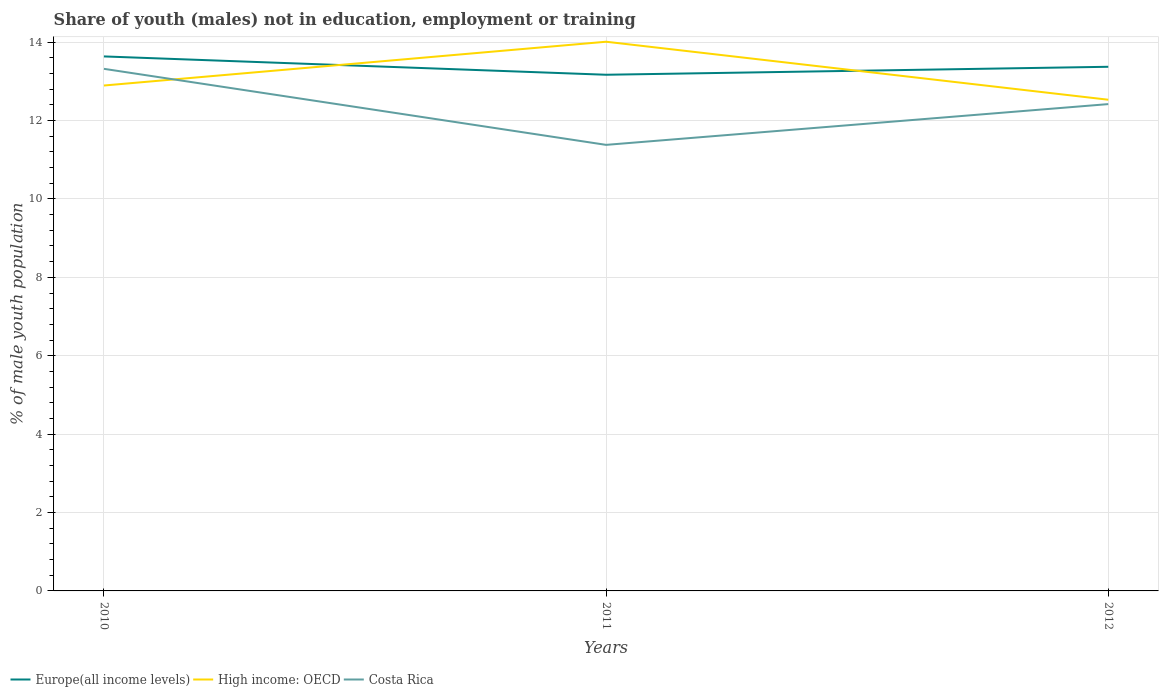How many different coloured lines are there?
Make the answer very short. 3. Does the line corresponding to High income: OECD intersect with the line corresponding to Europe(all income levels)?
Provide a succinct answer. Yes. Across all years, what is the maximum percentage of unemployed males population in in Costa Rica?
Your response must be concise. 11.38. In which year was the percentage of unemployed males population in in Costa Rica maximum?
Offer a very short reply. 2011. What is the total percentage of unemployed males population in in High income: OECD in the graph?
Your answer should be compact. 0.36. What is the difference between the highest and the second highest percentage of unemployed males population in in Europe(all income levels)?
Keep it short and to the point. 0.47. What is the difference between the highest and the lowest percentage of unemployed males population in in High income: OECD?
Provide a succinct answer. 1. How many years are there in the graph?
Your answer should be very brief. 3. Does the graph contain grids?
Your response must be concise. Yes. Where does the legend appear in the graph?
Provide a succinct answer. Bottom left. How many legend labels are there?
Offer a terse response. 3. What is the title of the graph?
Provide a succinct answer. Share of youth (males) not in education, employment or training. Does "Sweden" appear as one of the legend labels in the graph?
Keep it short and to the point. No. What is the label or title of the Y-axis?
Keep it short and to the point. % of male youth population. What is the % of male youth population of Europe(all income levels) in 2010?
Your answer should be very brief. 13.64. What is the % of male youth population in High income: OECD in 2010?
Offer a very short reply. 12.89. What is the % of male youth population in Costa Rica in 2010?
Provide a short and direct response. 13.32. What is the % of male youth population of Europe(all income levels) in 2011?
Offer a very short reply. 13.17. What is the % of male youth population of High income: OECD in 2011?
Your response must be concise. 14.01. What is the % of male youth population of Costa Rica in 2011?
Offer a very short reply. 11.38. What is the % of male youth population of Europe(all income levels) in 2012?
Provide a short and direct response. 13.37. What is the % of male youth population in High income: OECD in 2012?
Your response must be concise. 12.53. What is the % of male youth population in Costa Rica in 2012?
Make the answer very short. 12.42. Across all years, what is the maximum % of male youth population in Europe(all income levels)?
Ensure brevity in your answer.  13.64. Across all years, what is the maximum % of male youth population of High income: OECD?
Offer a very short reply. 14.01. Across all years, what is the maximum % of male youth population in Costa Rica?
Offer a terse response. 13.32. Across all years, what is the minimum % of male youth population of Europe(all income levels)?
Keep it short and to the point. 13.17. Across all years, what is the minimum % of male youth population in High income: OECD?
Your answer should be compact. 12.53. Across all years, what is the minimum % of male youth population in Costa Rica?
Your answer should be compact. 11.38. What is the total % of male youth population in Europe(all income levels) in the graph?
Your response must be concise. 40.18. What is the total % of male youth population of High income: OECD in the graph?
Make the answer very short. 39.44. What is the total % of male youth population in Costa Rica in the graph?
Your response must be concise. 37.12. What is the difference between the % of male youth population of Europe(all income levels) in 2010 and that in 2011?
Ensure brevity in your answer.  0.47. What is the difference between the % of male youth population in High income: OECD in 2010 and that in 2011?
Your answer should be compact. -1.12. What is the difference between the % of male youth population in Costa Rica in 2010 and that in 2011?
Your response must be concise. 1.94. What is the difference between the % of male youth population of Europe(all income levels) in 2010 and that in 2012?
Offer a terse response. 0.26. What is the difference between the % of male youth population of High income: OECD in 2010 and that in 2012?
Your answer should be very brief. 0.36. What is the difference between the % of male youth population of Europe(all income levels) in 2011 and that in 2012?
Your answer should be very brief. -0.2. What is the difference between the % of male youth population of High income: OECD in 2011 and that in 2012?
Offer a very short reply. 1.48. What is the difference between the % of male youth population in Costa Rica in 2011 and that in 2012?
Keep it short and to the point. -1.04. What is the difference between the % of male youth population in Europe(all income levels) in 2010 and the % of male youth population in High income: OECD in 2011?
Make the answer very short. -0.37. What is the difference between the % of male youth population of Europe(all income levels) in 2010 and the % of male youth population of Costa Rica in 2011?
Provide a succinct answer. 2.26. What is the difference between the % of male youth population of High income: OECD in 2010 and the % of male youth population of Costa Rica in 2011?
Offer a terse response. 1.51. What is the difference between the % of male youth population in Europe(all income levels) in 2010 and the % of male youth population in High income: OECD in 2012?
Ensure brevity in your answer.  1.1. What is the difference between the % of male youth population of Europe(all income levels) in 2010 and the % of male youth population of Costa Rica in 2012?
Your answer should be compact. 1.22. What is the difference between the % of male youth population in High income: OECD in 2010 and the % of male youth population in Costa Rica in 2012?
Your answer should be very brief. 0.47. What is the difference between the % of male youth population in Europe(all income levels) in 2011 and the % of male youth population in High income: OECD in 2012?
Give a very brief answer. 0.64. What is the difference between the % of male youth population of Europe(all income levels) in 2011 and the % of male youth population of Costa Rica in 2012?
Your answer should be very brief. 0.75. What is the difference between the % of male youth population of High income: OECD in 2011 and the % of male youth population of Costa Rica in 2012?
Make the answer very short. 1.59. What is the average % of male youth population in Europe(all income levels) per year?
Your answer should be compact. 13.39. What is the average % of male youth population of High income: OECD per year?
Offer a very short reply. 13.15. What is the average % of male youth population of Costa Rica per year?
Your answer should be very brief. 12.37. In the year 2010, what is the difference between the % of male youth population of Europe(all income levels) and % of male youth population of High income: OECD?
Your answer should be very brief. 0.74. In the year 2010, what is the difference between the % of male youth population of Europe(all income levels) and % of male youth population of Costa Rica?
Your answer should be compact. 0.32. In the year 2010, what is the difference between the % of male youth population in High income: OECD and % of male youth population in Costa Rica?
Keep it short and to the point. -0.43. In the year 2011, what is the difference between the % of male youth population in Europe(all income levels) and % of male youth population in High income: OECD?
Keep it short and to the point. -0.84. In the year 2011, what is the difference between the % of male youth population in Europe(all income levels) and % of male youth population in Costa Rica?
Provide a short and direct response. 1.79. In the year 2011, what is the difference between the % of male youth population of High income: OECD and % of male youth population of Costa Rica?
Make the answer very short. 2.63. In the year 2012, what is the difference between the % of male youth population in Europe(all income levels) and % of male youth population in High income: OECD?
Provide a succinct answer. 0.84. In the year 2012, what is the difference between the % of male youth population of Europe(all income levels) and % of male youth population of Costa Rica?
Keep it short and to the point. 0.95. In the year 2012, what is the difference between the % of male youth population of High income: OECD and % of male youth population of Costa Rica?
Provide a short and direct response. 0.11. What is the ratio of the % of male youth population in Europe(all income levels) in 2010 to that in 2011?
Offer a terse response. 1.04. What is the ratio of the % of male youth population in High income: OECD in 2010 to that in 2011?
Provide a short and direct response. 0.92. What is the ratio of the % of male youth population in Costa Rica in 2010 to that in 2011?
Give a very brief answer. 1.17. What is the ratio of the % of male youth population in Europe(all income levels) in 2010 to that in 2012?
Give a very brief answer. 1.02. What is the ratio of the % of male youth population of High income: OECD in 2010 to that in 2012?
Keep it short and to the point. 1.03. What is the ratio of the % of male youth population of Costa Rica in 2010 to that in 2012?
Your response must be concise. 1.07. What is the ratio of the % of male youth population of Europe(all income levels) in 2011 to that in 2012?
Offer a very short reply. 0.98. What is the ratio of the % of male youth population in High income: OECD in 2011 to that in 2012?
Your response must be concise. 1.12. What is the ratio of the % of male youth population in Costa Rica in 2011 to that in 2012?
Your response must be concise. 0.92. What is the difference between the highest and the second highest % of male youth population in Europe(all income levels)?
Make the answer very short. 0.26. What is the difference between the highest and the second highest % of male youth population in High income: OECD?
Your response must be concise. 1.12. What is the difference between the highest and the second highest % of male youth population of Costa Rica?
Provide a short and direct response. 0.9. What is the difference between the highest and the lowest % of male youth population in Europe(all income levels)?
Ensure brevity in your answer.  0.47. What is the difference between the highest and the lowest % of male youth population of High income: OECD?
Offer a very short reply. 1.48. What is the difference between the highest and the lowest % of male youth population of Costa Rica?
Offer a very short reply. 1.94. 